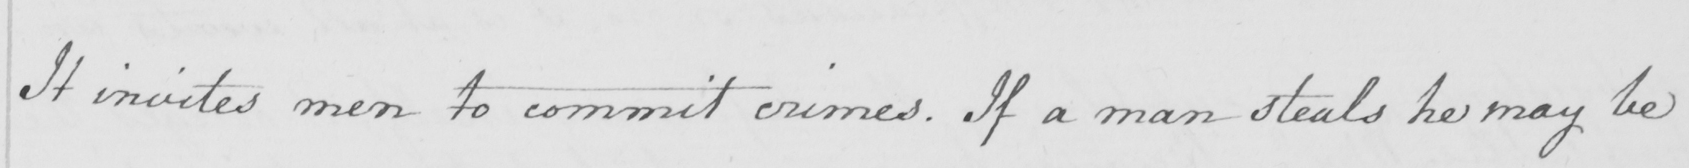What does this handwritten line say? It invites men to commit crimes . If a man steals he may be 